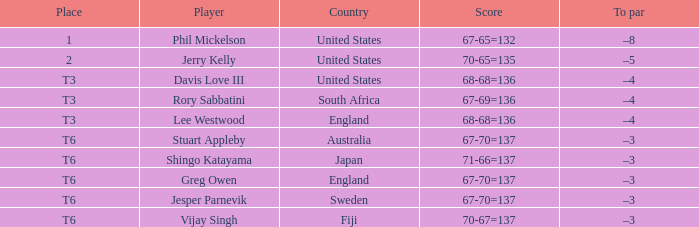Identify the score of vijay singh. 70-67=137. 